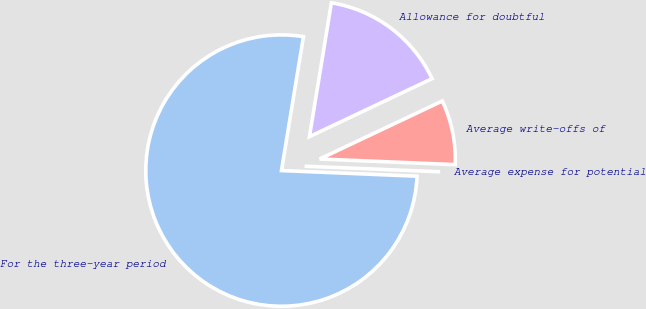Convert chart. <chart><loc_0><loc_0><loc_500><loc_500><pie_chart><fcel>For the three-year period<fcel>Average expense for potential<fcel>Average write-offs of<fcel>Allowance for doubtful<nl><fcel>76.92%<fcel>0.0%<fcel>7.69%<fcel>15.38%<nl></chart> 